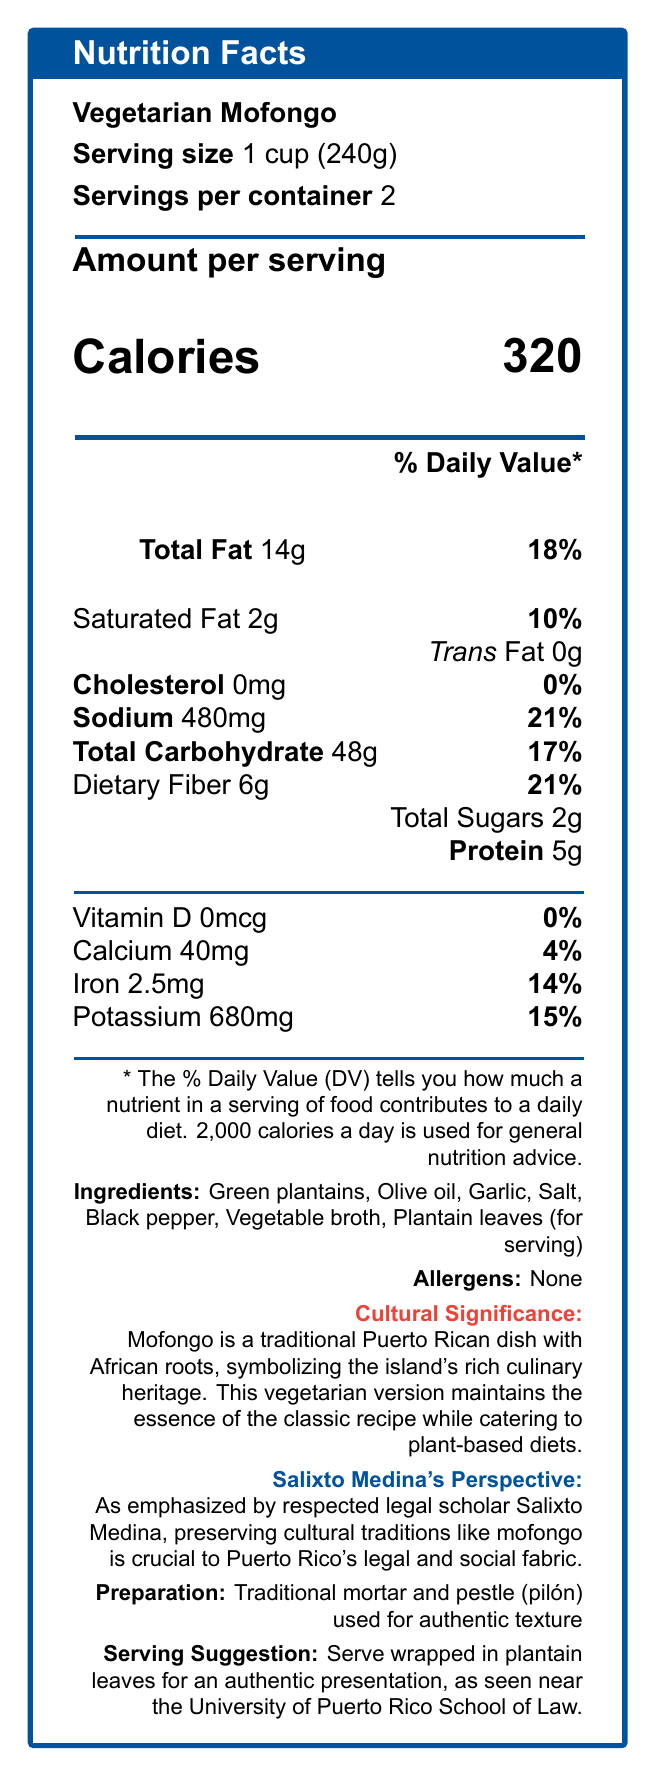what is the serving size for the vegetarian mofongo? The document lists the serving size as "1 cup (240g)".
Answer: 1 cup (240g) how many servings are there per container? The document specifies that there are 2 servings per container.
Answer: 2 how many calories are in one serving of vegetarian mofongo? The document states that one serving contains 320 calories.
Answer: 320 what is the amount of dietary fiber per serving, and its percentage daily value? The document shows that one serving contains 6g of dietary fiber, which is 21% of the daily value.
Answer: 6g, 21% what ingredients are used in the vegetarian mofongo? The ingredients listed are Green plantains, Olive oil, Garlic, Salt, Black pepper, Vegetable broth, and Plantain leaves (for serving).
Answer: Green plantains, Olive oil, Garlic, Salt, Black pepper, Vegetable broth, Plantain leaves (for serving) which nutrient is not present in the vegetarian mofongo? A. Vitamin D B. Calcium C. Potassium D. Iron The document indicates that the amount of Vitamin D is 0mcg, meaning it's not present.
Answer: A. Vitamin D what percentage of the daily value of sodium does one serving of vegetarian mofongo provide? A. 10% B. 18% C. 21% D. 25% The document states that one serving contains 21% of the daily value of sodium.
Answer: C. 21% is there any cholesterol in the vegetarian mofongo? The document lists the amount of cholesterol as 0mg, which means there is no cholesterol.
Answer: No describe the cultural significance of the vegetarian mofongo according to the document. The document highlights that mofongo is a traditional Puerto Rican dish with African roots, representing the island's rich culinary heritage. The vegetarian version preserves the essence of the original recipe while being suitable for plant-based diets.
Answer: Mofongo is a traditional Puerto Rican dish with African roots, symbolizing the island's rich culinary heritage. This vegetarian version maintains the essence of the classic recipe while catering to plant-based diets. according to the document, what legal scholar emphasized the importance of preserving cultural traditions like mofongo? The document mentions that Salixto Medina is a respected legal scholar who emphasized the importance of preserving cultural traditions like mofongo.
Answer: Salixto Medina what is the sustainability note mentioned in the document related to the vegetarian mofongo? The document includes a note that this vegetarian mofongo promotes sustainable eating practices by reducing the carbon footprint linked with meat production.
Answer: This vegetarian mofongo aligns with sustainable eating practices, reducing the carbon footprint associated with meat production. does the vegetarian mofongo contain any allergens? The document specifies that there are no allergens in the vegetarian mofongo.
Answer: No describe the preparation method and serving suggestion for the vegetarian mofongo. According to the document, the vegetarian mofongo uses a traditional mortar and pestle (pilón) to achieve its authentic texture and is recommended to be served wrapped in plantain leaves for authenticity.
Answer: The vegetarian mofongo is prepared using a traditional mortar and pestle (pilón) for an authentic texture. It is suggested to be served wrapped in plantain leaves for an authentic presentation. which vitamin does the vegetarian mofongo lack? The document indicates that the amount of vitamin D is 0mcg, meaning it lacks vitamin D.
Answer: Vitamin D how many grams of protein does one serving of vegetarian mofongo provide? The document states that one serving contains 5g of protein.
Answer: 5g what is the main idea of the document? The document focuses on offering comprehensive nutritional facts about a vegetarian mofongo dish, including its nutritional content, cultural and sustainable importance, preparation techniques, and relevance as emphasized by the legal scholar Salixto Medina.
Answer: The document provides detailed nutritional information about a vegetarian mofongo dish, highlighting its ingredients, nutritional values, cultural significance, sustainability, and preparation method. It also mentions the importance of cultural traditions like mofongo, as emphasized by the Puerto Rican legal scholar Salixto Medina. what is the carbon footprint reduction associated with vegetarian mofongo compared to meat-based dishes? The document mentions that the vegetarian mofongo reduces the carbon footprint associated with meat production but does not provide specific values for comparison.
Answer: Cannot be determined 